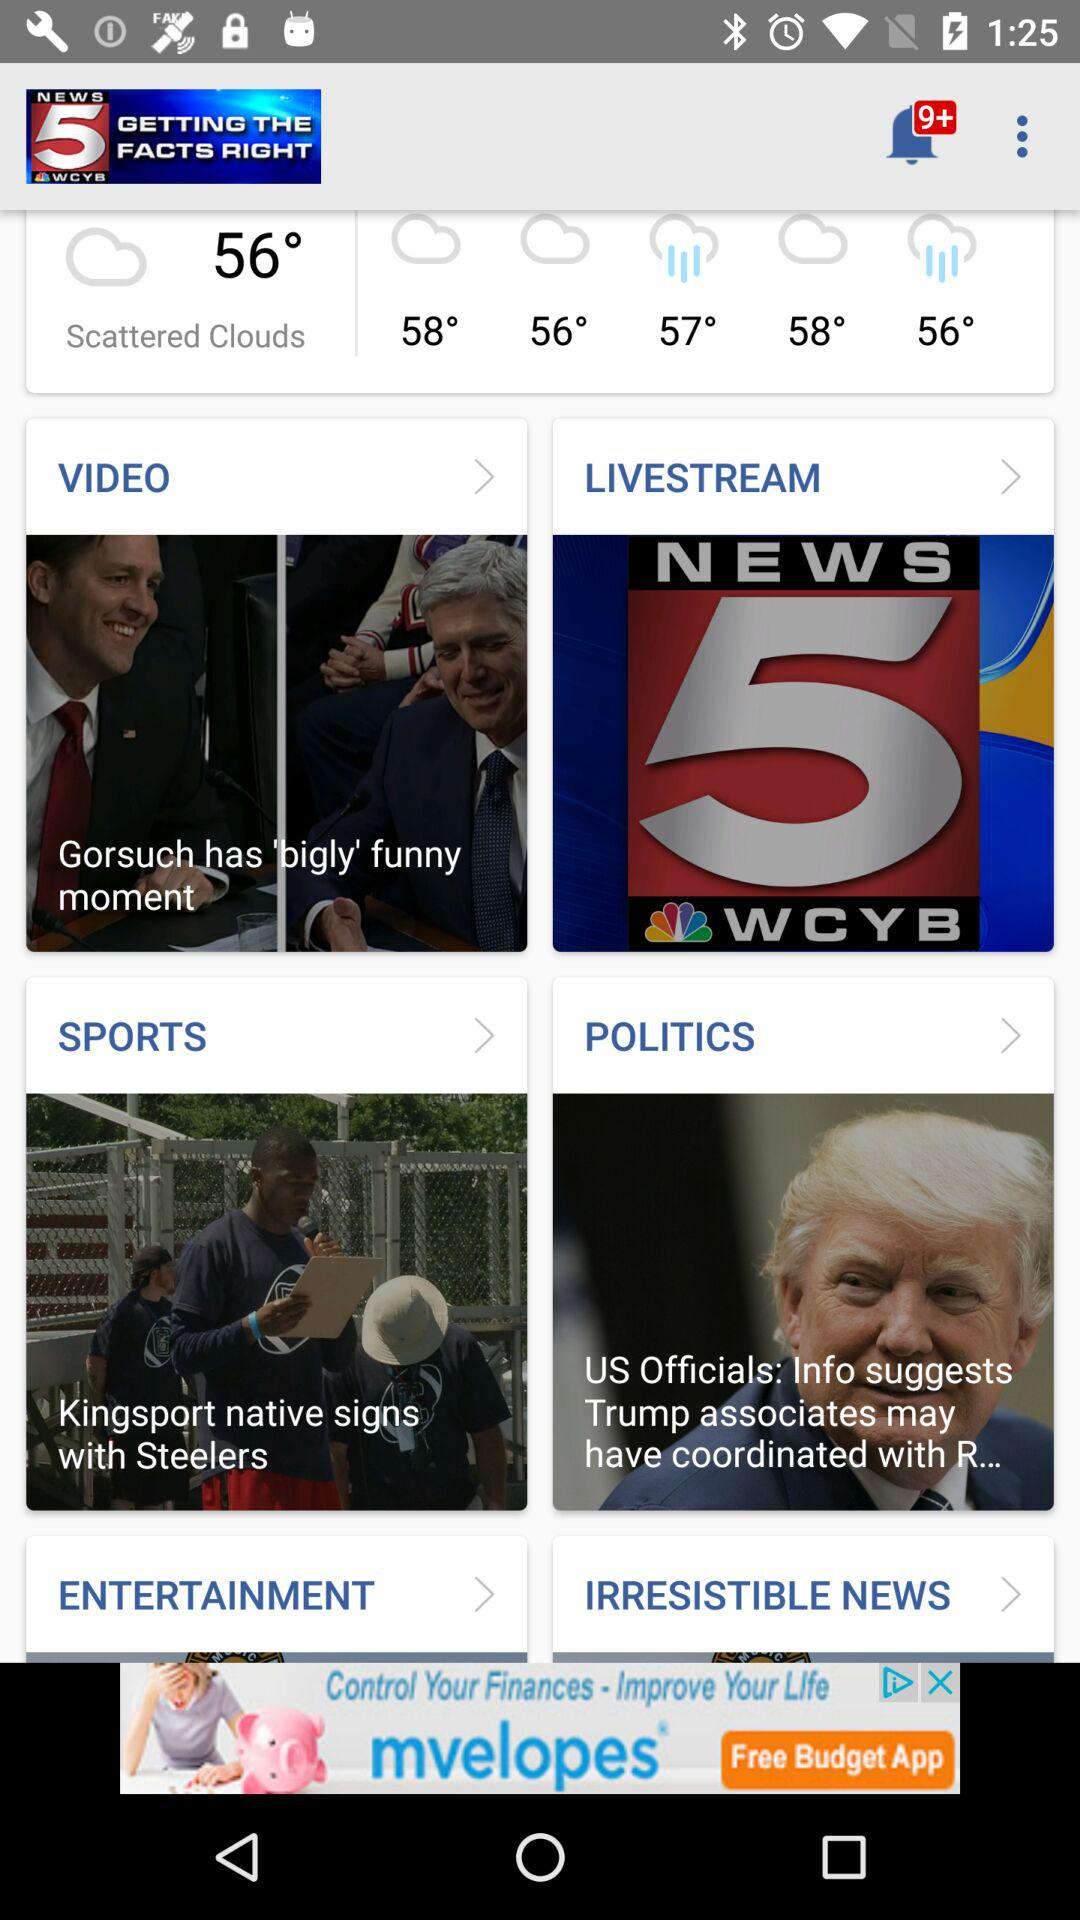How many notifications in total are there? There are 9 notifications. 